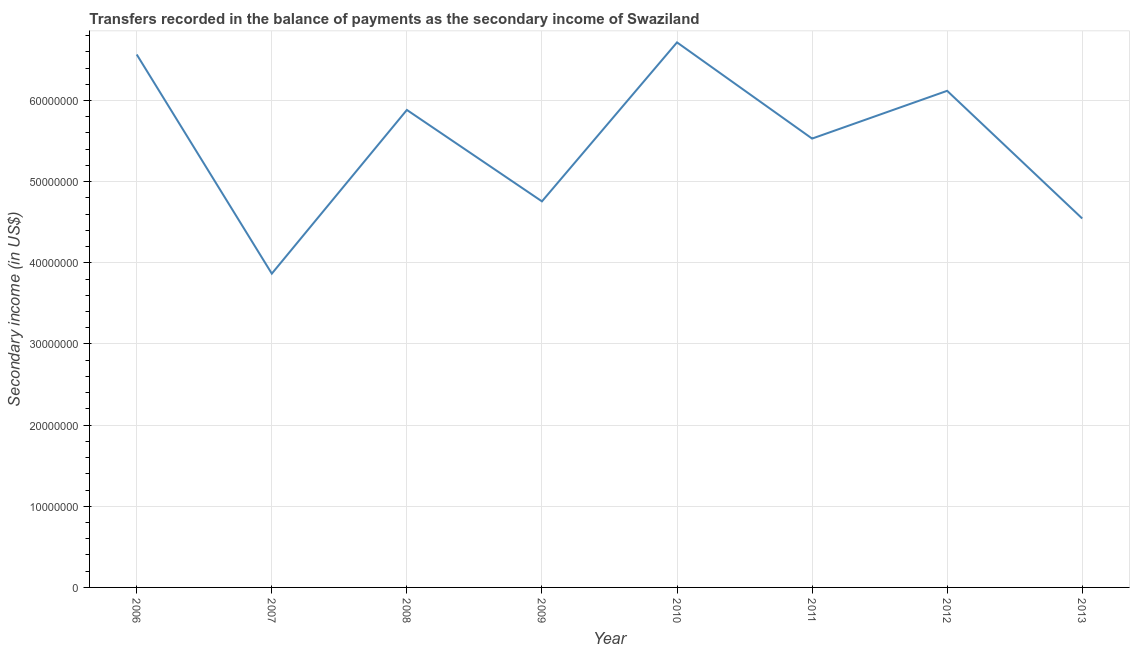What is the amount of secondary income in 2008?
Ensure brevity in your answer.  5.88e+07. Across all years, what is the maximum amount of secondary income?
Offer a terse response. 6.72e+07. Across all years, what is the minimum amount of secondary income?
Give a very brief answer. 3.87e+07. What is the sum of the amount of secondary income?
Make the answer very short. 4.40e+08. What is the difference between the amount of secondary income in 2006 and 2012?
Offer a terse response. 4.48e+06. What is the average amount of secondary income per year?
Your answer should be very brief. 5.50e+07. What is the median amount of secondary income?
Offer a terse response. 5.71e+07. In how many years, is the amount of secondary income greater than 52000000 US$?
Your response must be concise. 5. What is the ratio of the amount of secondary income in 2006 to that in 2010?
Your response must be concise. 0.98. Is the amount of secondary income in 2009 less than that in 2012?
Your response must be concise. Yes. What is the difference between the highest and the second highest amount of secondary income?
Your answer should be compact. 1.49e+06. What is the difference between the highest and the lowest amount of secondary income?
Keep it short and to the point. 2.85e+07. What is the difference between two consecutive major ticks on the Y-axis?
Provide a short and direct response. 1.00e+07. What is the title of the graph?
Provide a succinct answer. Transfers recorded in the balance of payments as the secondary income of Swaziland. What is the label or title of the Y-axis?
Provide a succinct answer. Secondary income (in US$). What is the Secondary income (in US$) in 2006?
Your answer should be very brief. 6.57e+07. What is the Secondary income (in US$) in 2007?
Keep it short and to the point. 3.87e+07. What is the Secondary income (in US$) of 2008?
Offer a terse response. 5.88e+07. What is the Secondary income (in US$) in 2009?
Provide a succinct answer. 4.76e+07. What is the Secondary income (in US$) of 2010?
Give a very brief answer. 6.72e+07. What is the Secondary income (in US$) of 2011?
Provide a short and direct response. 5.53e+07. What is the Secondary income (in US$) in 2012?
Your response must be concise. 6.12e+07. What is the Secondary income (in US$) of 2013?
Make the answer very short. 4.55e+07. What is the difference between the Secondary income (in US$) in 2006 and 2007?
Your response must be concise. 2.70e+07. What is the difference between the Secondary income (in US$) in 2006 and 2008?
Ensure brevity in your answer.  6.83e+06. What is the difference between the Secondary income (in US$) in 2006 and 2009?
Your answer should be very brief. 1.81e+07. What is the difference between the Secondary income (in US$) in 2006 and 2010?
Give a very brief answer. -1.49e+06. What is the difference between the Secondary income (in US$) in 2006 and 2011?
Give a very brief answer. 1.04e+07. What is the difference between the Secondary income (in US$) in 2006 and 2012?
Keep it short and to the point. 4.48e+06. What is the difference between the Secondary income (in US$) in 2006 and 2013?
Provide a short and direct response. 2.02e+07. What is the difference between the Secondary income (in US$) in 2007 and 2008?
Offer a very short reply. -2.02e+07. What is the difference between the Secondary income (in US$) in 2007 and 2009?
Provide a short and direct response. -8.91e+06. What is the difference between the Secondary income (in US$) in 2007 and 2010?
Provide a succinct answer. -2.85e+07. What is the difference between the Secondary income (in US$) in 2007 and 2011?
Ensure brevity in your answer.  -1.66e+07. What is the difference between the Secondary income (in US$) in 2007 and 2012?
Your response must be concise. -2.25e+07. What is the difference between the Secondary income (in US$) in 2007 and 2013?
Your answer should be compact. -6.80e+06. What is the difference between the Secondary income (in US$) in 2008 and 2009?
Offer a terse response. 1.13e+07. What is the difference between the Secondary income (in US$) in 2008 and 2010?
Offer a very short reply. -8.32e+06. What is the difference between the Secondary income (in US$) in 2008 and 2011?
Offer a terse response. 3.53e+06. What is the difference between the Secondary income (in US$) in 2008 and 2012?
Keep it short and to the point. -2.36e+06. What is the difference between the Secondary income (in US$) in 2008 and 2013?
Provide a succinct answer. 1.34e+07. What is the difference between the Secondary income (in US$) in 2009 and 2010?
Your response must be concise. -1.96e+07. What is the difference between the Secondary income (in US$) in 2009 and 2011?
Give a very brief answer. -7.74e+06. What is the difference between the Secondary income (in US$) in 2009 and 2012?
Provide a succinct answer. -1.36e+07. What is the difference between the Secondary income (in US$) in 2009 and 2013?
Offer a very short reply. 2.11e+06. What is the difference between the Secondary income (in US$) in 2010 and 2011?
Keep it short and to the point. 1.19e+07. What is the difference between the Secondary income (in US$) in 2010 and 2012?
Provide a short and direct response. 5.97e+06. What is the difference between the Secondary income (in US$) in 2010 and 2013?
Keep it short and to the point. 2.17e+07. What is the difference between the Secondary income (in US$) in 2011 and 2012?
Offer a terse response. -5.88e+06. What is the difference between the Secondary income (in US$) in 2011 and 2013?
Make the answer very short. 9.85e+06. What is the difference between the Secondary income (in US$) in 2012 and 2013?
Offer a terse response. 1.57e+07. What is the ratio of the Secondary income (in US$) in 2006 to that in 2007?
Your answer should be very brief. 1.7. What is the ratio of the Secondary income (in US$) in 2006 to that in 2008?
Provide a short and direct response. 1.12. What is the ratio of the Secondary income (in US$) in 2006 to that in 2009?
Make the answer very short. 1.38. What is the ratio of the Secondary income (in US$) in 2006 to that in 2010?
Offer a terse response. 0.98. What is the ratio of the Secondary income (in US$) in 2006 to that in 2011?
Give a very brief answer. 1.19. What is the ratio of the Secondary income (in US$) in 2006 to that in 2012?
Your answer should be compact. 1.07. What is the ratio of the Secondary income (in US$) in 2006 to that in 2013?
Offer a terse response. 1.44. What is the ratio of the Secondary income (in US$) in 2007 to that in 2008?
Offer a very short reply. 0.66. What is the ratio of the Secondary income (in US$) in 2007 to that in 2009?
Make the answer very short. 0.81. What is the ratio of the Secondary income (in US$) in 2007 to that in 2010?
Your response must be concise. 0.58. What is the ratio of the Secondary income (in US$) in 2007 to that in 2011?
Offer a terse response. 0.7. What is the ratio of the Secondary income (in US$) in 2007 to that in 2012?
Your answer should be very brief. 0.63. What is the ratio of the Secondary income (in US$) in 2007 to that in 2013?
Provide a succinct answer. 0.85. What is the ratio of the Secondary income (in US$) in 2008 to that in 2009?
Provide a succinct answer. 1.24. What is the ratio of the Secondary income (in US$) in 2008 to that in 2010?
Provide a succinct answer. 0.88. What is the ratio of the Secondary income (in US$) in 2008 to that in 2011?
Provide a short and direct response. 1.06. What is the ratio of the Secondary income (in US$) in 2008 to that in 2012?
Keep it short and to the point. 0.96. What is the ratio of the Secondary income (in US$) in 2008 to that in 2013?
Give a very brief answer. 1.29. What is the ratio of the Secondary income (in US$) in 2009 to that in 2010?
Give a very brief answer. 0.71. What is the ratio of the Secondary income (in US$) in 2009 to that in 2011?
Offer a terse response. 0.86. What is the ratio of the Secondary income (in US$) in 2009 to that in 2012?
Provide a short and direct response. 0.78. What is the ratio of the Secondary income (in US$) in 2009 to that in 2013?
Ensure brevity in your answer.  1.05. What is the ratio of the Secondary income (in US$) in 2010 to that in 2011?
Keep it short and to the point. 1.21. What is the ratio of the Secondary income (in US$) in 2010 to that in 2012?
Give a very brief answer. 1.1. What is the ratio of the Secondary income (in US$) in 2010 to that in 2013?
Make the answer very short. 1.48. What is the ratio of the Secondary income (in US$) in 2011 to that in 2012?
Provide a succinct answer. 0.9. What is the ratio of the Secondary income (in US$) in 2011 to that in 2013?
Offer a terse response. 1.22. What is the ratio of the Secondary income (in US$) in 2012 to that in 2013?
Your answer should be compact. 1.35. 